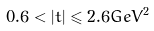Convert formula to latex. <formula><loc_0><loc_0><loc_500><loc_500>0 . 6 < | t | \leqslant 2 . 6 G e V ^ { 2 }</formula> 